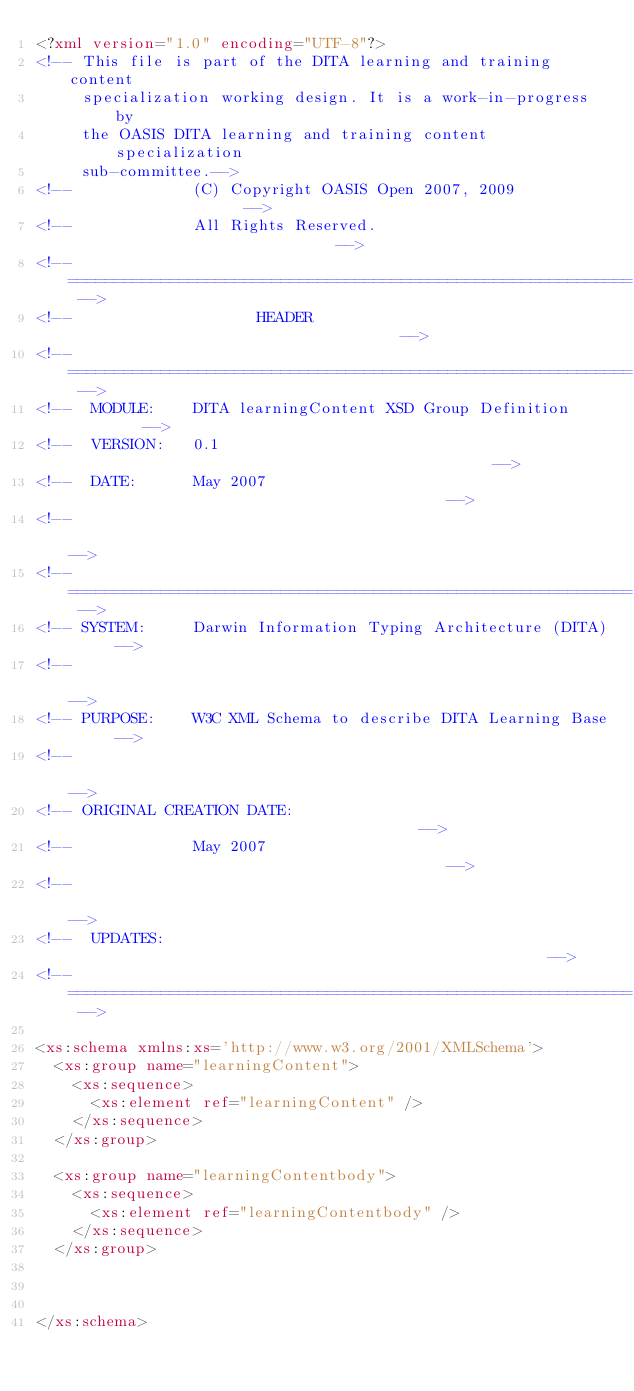<code> <loc_0><loc_0><loc_500><loc_500><_XML_><?xml version="1.0" encoding="UTF-8"?>
<!-- This file is part of the DITA learning and training content 
     specialization working design. It is a work-in-progress by
     the OASIS DITA learning and training content specialization 
     sub-committee.-->
<!--             (C) Copyright OASIS Open 2007, 2009                    -->
<!--             All Rights Reserved.                              -->
<!-- ============================================================= -->
<!--                    HEADER                                     -->
<!-- ============================================================= -->
<!--  MODULE:    DITA learningContent XSD Group Definition         -->
<!--  VERSION:   0.1                                               -->
<!--  DATE:      May 2007                                          -->
<!--                                                               -->
<!-- ============================================================= -->
<!-- SYSTEM:     Darwin Information Typing Architecture (DITA)     -->
<!--                                                               -->
<!-- PURPOSE:    W3C XML Schema to describe DITA Learning Base     -->
<!--                                                               -->
<!-- ORIGINAL CREATION DATE:                                       -->
<!--             May 2007                                          -->
<!--                                                               -->
<!--  UPDATES:                                                     -->
<!-- ============================================================= -->

<xs:schema xmlns:xs='http://www.w3.org/2001/XMLSchema'>
  <xs:group name="learningContent">
  	<xs:sequence>
  	  <xs:element ref="learningContent" />
  	</xs:sequence>
  </xs:group>

  <xs:group name="learningContentbody">
  	<xs:sequence>
  	  <xs:element ref="learningContentbody" />
  	</xs:sequence>
  </xs:group>

  

</xs:schema></code> 